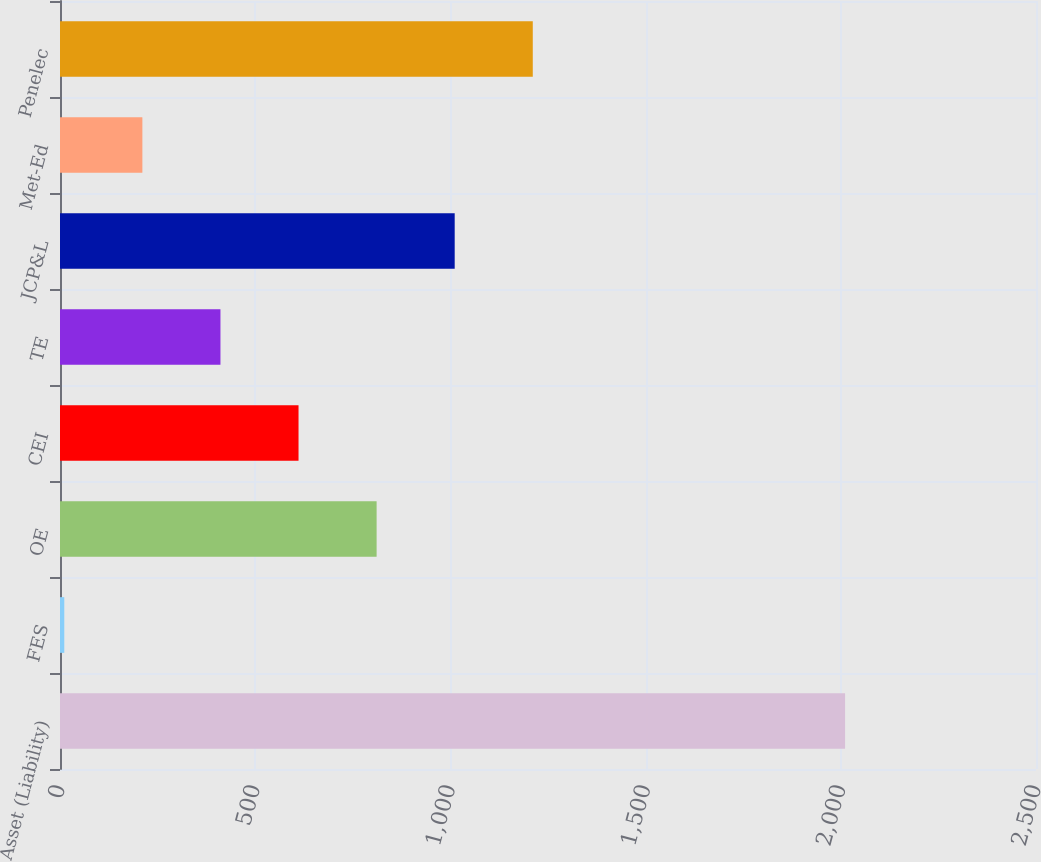Convert chart to OTSL. <chart><loc_0><loc_0><loc_500><loc_500><bar_chart><fcel>Asset (Liability)<fcel>FES<fcel>OE<fcel>CEI<fcel>TE<fcel>JCP&L<fcel>Met-Ed<fcel>Penelec<nl><fcel>2011<fcel>11<fcel>811<fcel>611<fcel>411<fcel>1011<fcel>211<fcel>1211<nl></chart> 